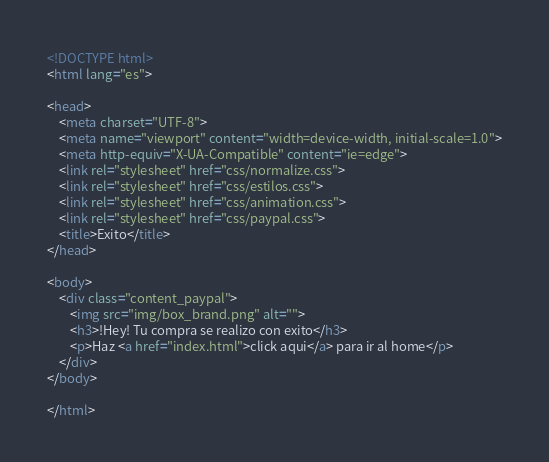Convert code to text. <code><loc_0><loc_0><loc_500><loc_500><_HTML_><!DOCTYPE html>
<html lang="es">

<head>
    <meta charset="UTF-8">
    <meta name="viewport" content="width=device-width, initial-scale=1.0">
    <meta http-equiv="X-UA-Compatible" content="ie=edge">
    <link rel="stylesheet" href="css/normalize.css">
    <link rel="stylesheet" href="css/estilos.css">
    <link rel="stylesheet" href="css/animation.css">
    <link rel="stylesheet" href="css/paypal.css">
    <title>Exito</title>
</head>

<body>
    <div class="content_paypal">
        <img src="img/box_brand.png" alt="">
        <h3>!Hey! Tu compra se realizo con exito</h3>
        <p>Haz <a href="index.html">click aqui</a> para ir al home</p>
    </div>
</body>

</html></code> 